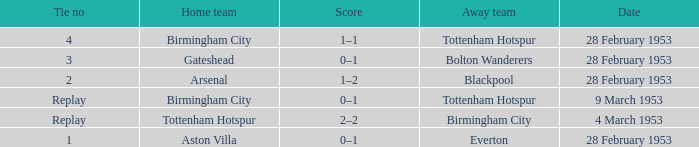Which Tie no has a Score of 0–1, and a Date of 9 march 1953? Replay. 